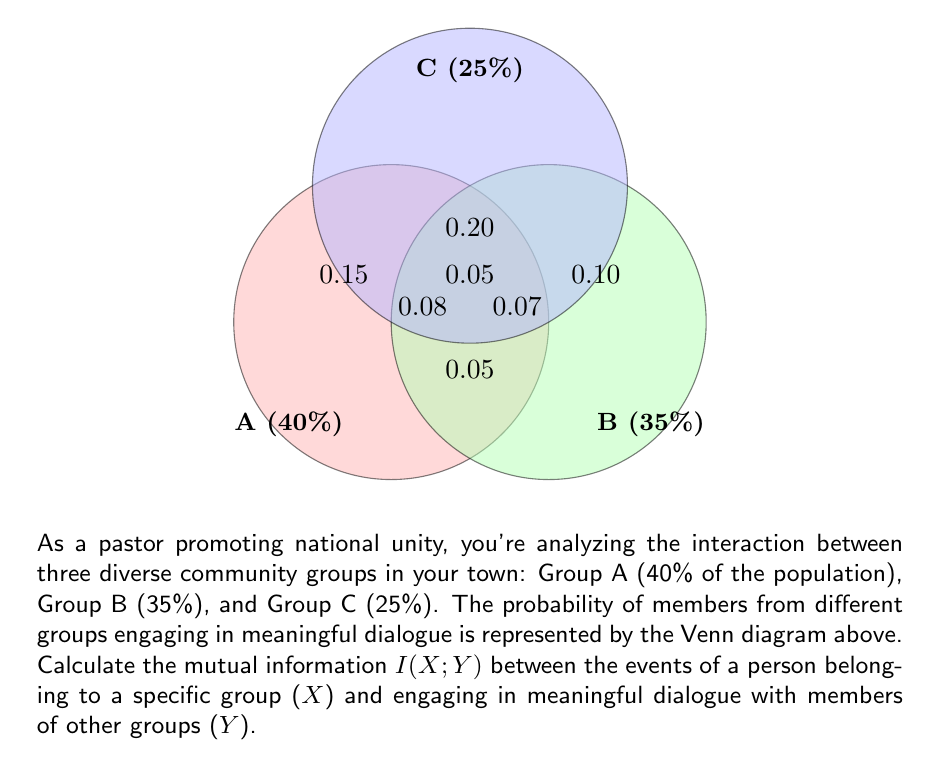Can you solve this math problem? To calculate the mutual information $I(X;Y)$, we'll follow these steps:

1) First, we need to calculate the probabilities:
   $P(X=A) = 0.40$, $P(X=B) = 0.35$, $P(X=C) = 0.25$
   $P(Y=1) = 0.15 + 0.10 + 0.05 + 0.20 + 0.08 + 0.07 + 0.05 = 0.70$ (probability of engaging in dialogue)
   $P(Y=0) = 1 - 0.70 = 0.30$ (probability of not engaging in dialogue)

2) Next, we calculate the joint probabilities $P(X,Y)$:
   $P(A,1) = 0.15 + 0.08 + 0.20 + 0.05 = 0.48$
   $P(B,1) = 0.10 + 0.07 + 0.20 + 0.05 = 0.42$
   $P(C,1) = 0.05 + 0.08 + 0.07 + 0.05 = 0.25$
   $P(A,0) = 0.40 - 0.48 = -0.08$ (adjusted to 0 as probability can't be negative)
   $P(B,0) = 0.35 - 0.42 = -0.07$ (adjusted to 0)
   $P(C,0) = 0.25 - 0.25 = 0$

3) The mutual information is calculated using the formula:
   $$I(X;Y) = \sum_{x \in X} \sum_{y \in Y} P(x,y) \log_2 \frac{P(x,y)}{P(x)P(y)}$$

4) Substituting the values:
   $$I(X;Y) = 0.48 \log_2 \frac{0.48}{0.40 \cdot 0.70} + 0.42 \log_2 \frac{0.42}{0.35 \cdot 0.70} + 0.25 \log_2 \frac{0.25}{0.25 \cdot 0.70}$$

5) Calculating:
   $$I(X;Y) = 0.48 \log_2 1.71 + 0.42 \log_2 1.71 + 0.25 \log_2 1.43$$
   $$I(X;Y) = 0.48 \cdot 0.775 + 0.42 \cdot 0.775 + 0.25 \cdot 0.516$$
   $$I(X;Y) = 0.372 + 0.326 + 0.129 = 0.827$$

Therefore, the mutual information $I(X;Y)$ is approximately 0.827 bits.
Answer: 0.827 bits 